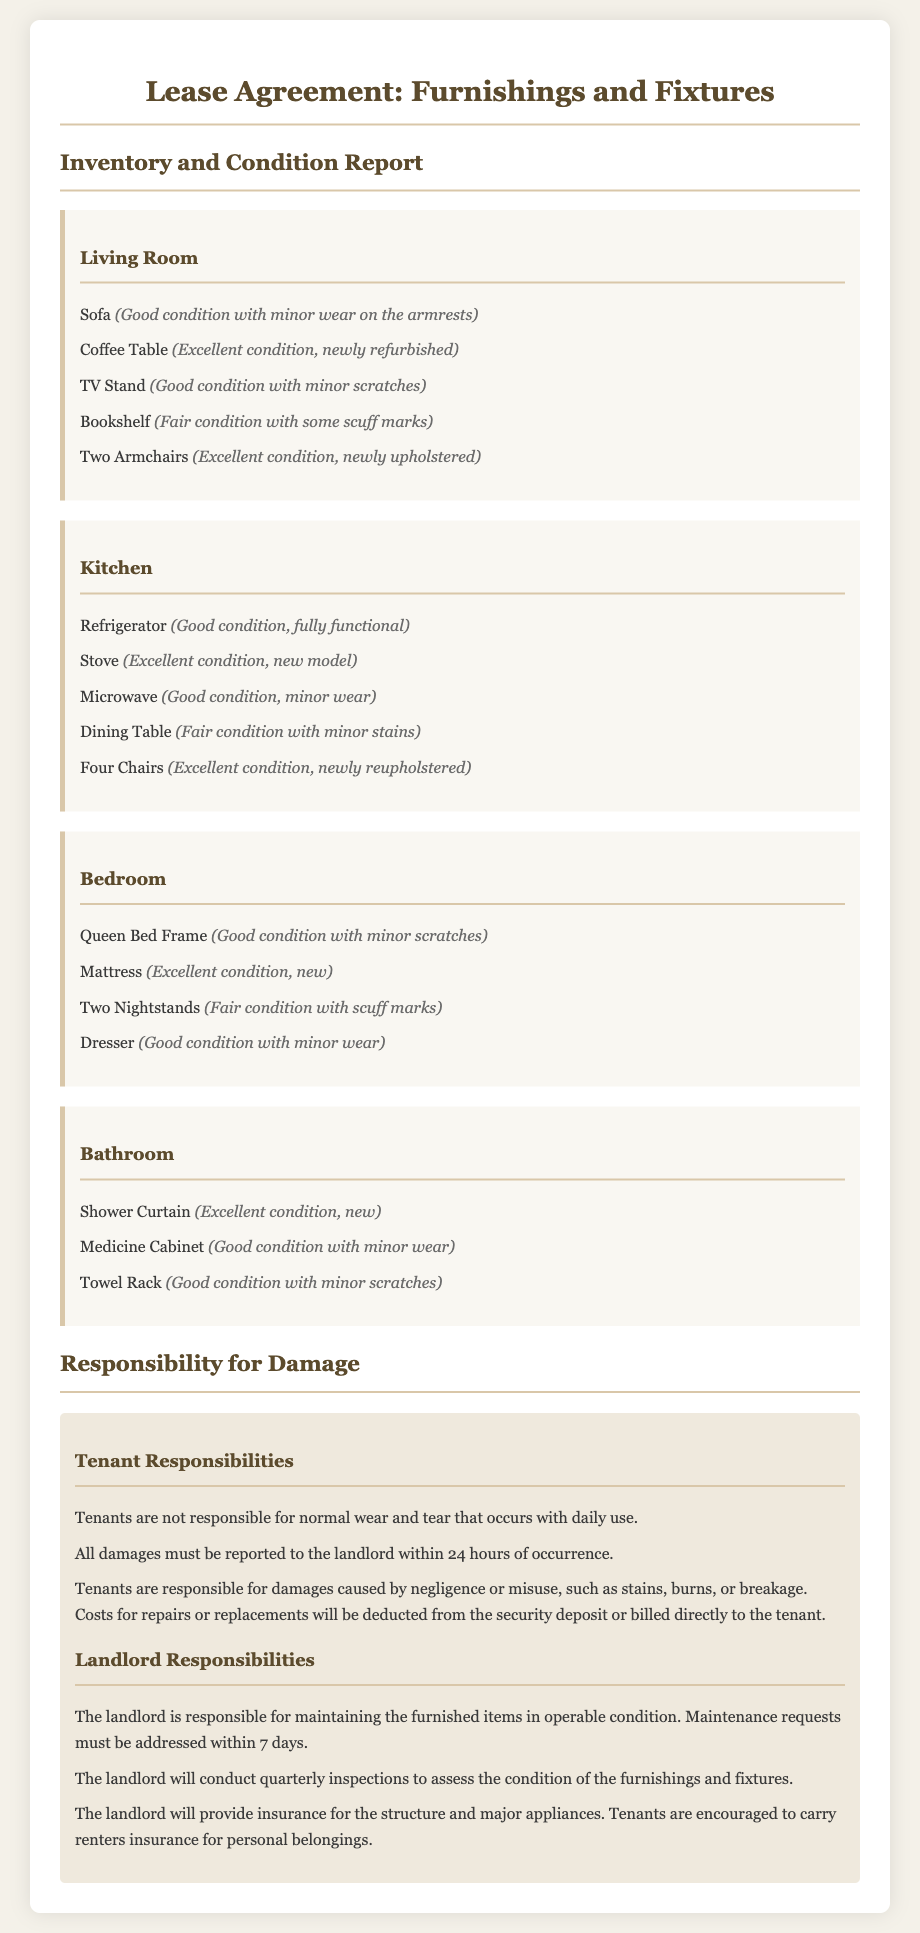What is the condition of the Sofa? The condition of the Sofa is noted in the document as "Good condition with minor wear on the armrests."
Answer: Good condition with minor wear on the armrests How many items are listed in the Living Room? The document lists five items in the Living Room.
Answer: Five What is the condition of the Microwave? The condition of the Microwave is mentioned as "Good condition, minor wear."
Answer: Good condition, minor wear Who is responsible for damages caused by negligence? The tenant is responsible for damages caused by negligence or misuse according to the document.
Answer: Tenant How often will the landlord conduct inspections? The landlord will conduct inspections quarterly to assess the condition of the furnishings and fixtures.
Answer: Quarterly What is the condition of the Shower Curtain? The condition of the Shower Curtain is specified as "Excellent condition, new."
Answer: Excellent condition, new What is the responsibility of tenants regarding normal wear and tear? Tenants are not responsible for normal wear and tear according to the lease agreement.
Answer: Not responsible How long do landlords have to address maintenance requests? Landlords must address maintenance requests within 7 days.
Answer: 7 days What must be reported to the landlord within 24 hours? All damages must be reported to the landlord within 24 hours of occurrence per the lease.
Answer: All damages 